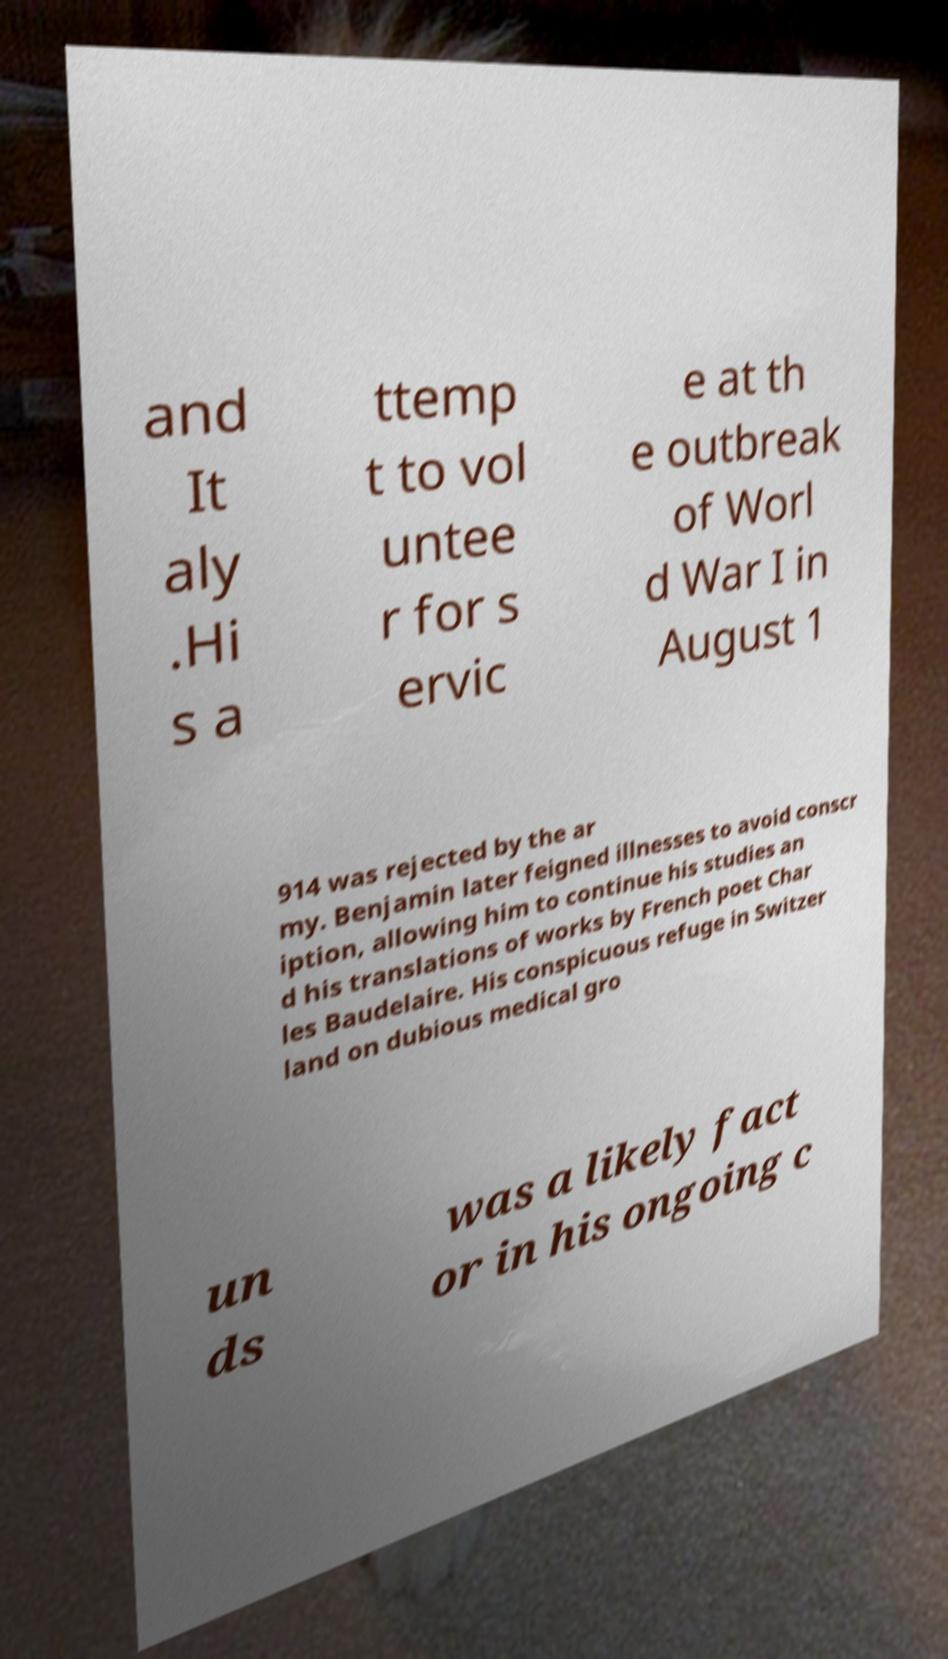Please identify and transcribe the text found in this image. and It aly .Hi s a ttemp t to vol untee r for s ervic e at th e outbreak of Worl d War I in August 1 914 was rejected by the ar my. Benjamin later feigned illnesses to avoid conscr iption, allowing him to continue his studies an d his translations of works by French poet Char les Baudelaire. His conspicuous refuge in Switzer land on dubious medical gro un ds was a likely fact or in his ongoing c 